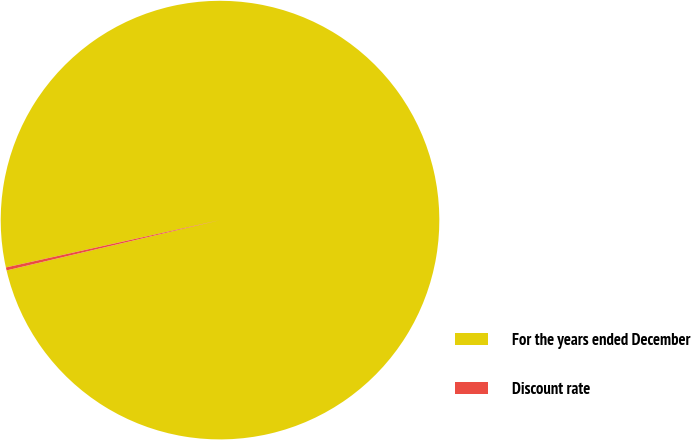<chart> <loc_0><loc_0><loc_500><loc_500><pie_chart><fcel>For the years ended December<fcel>Discount rate<nl><fcel>99.78%<fcel>0.22%<nl></chart> 